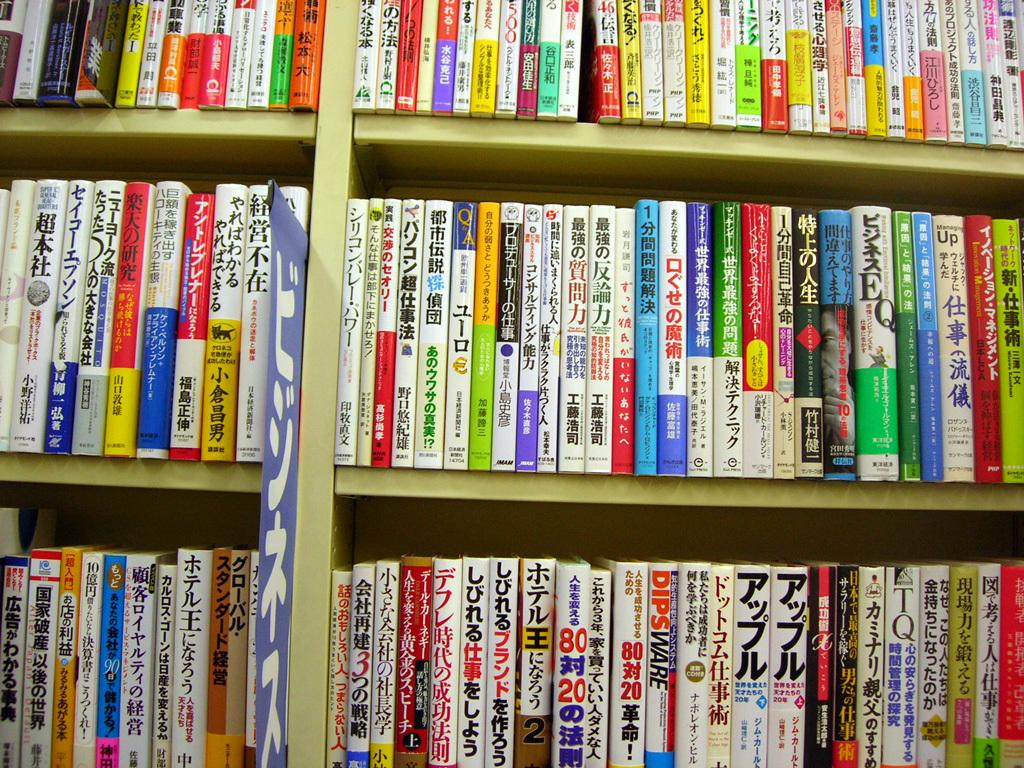What type of structure can be seen in the image? There are racks in the image. What items are stored on the racks? There are books present on the racks. Where is the suit stored in the image? There is no suit present in the image; it only features racks with books. 